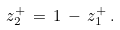Convert formula to latex. <formula><loc_0><loc_0><loc_500><loc_500>z _ { 2 } ^ { + } \, = \, 1 \, - \, z _ { 1 } ^ { + } \, .</formula> 